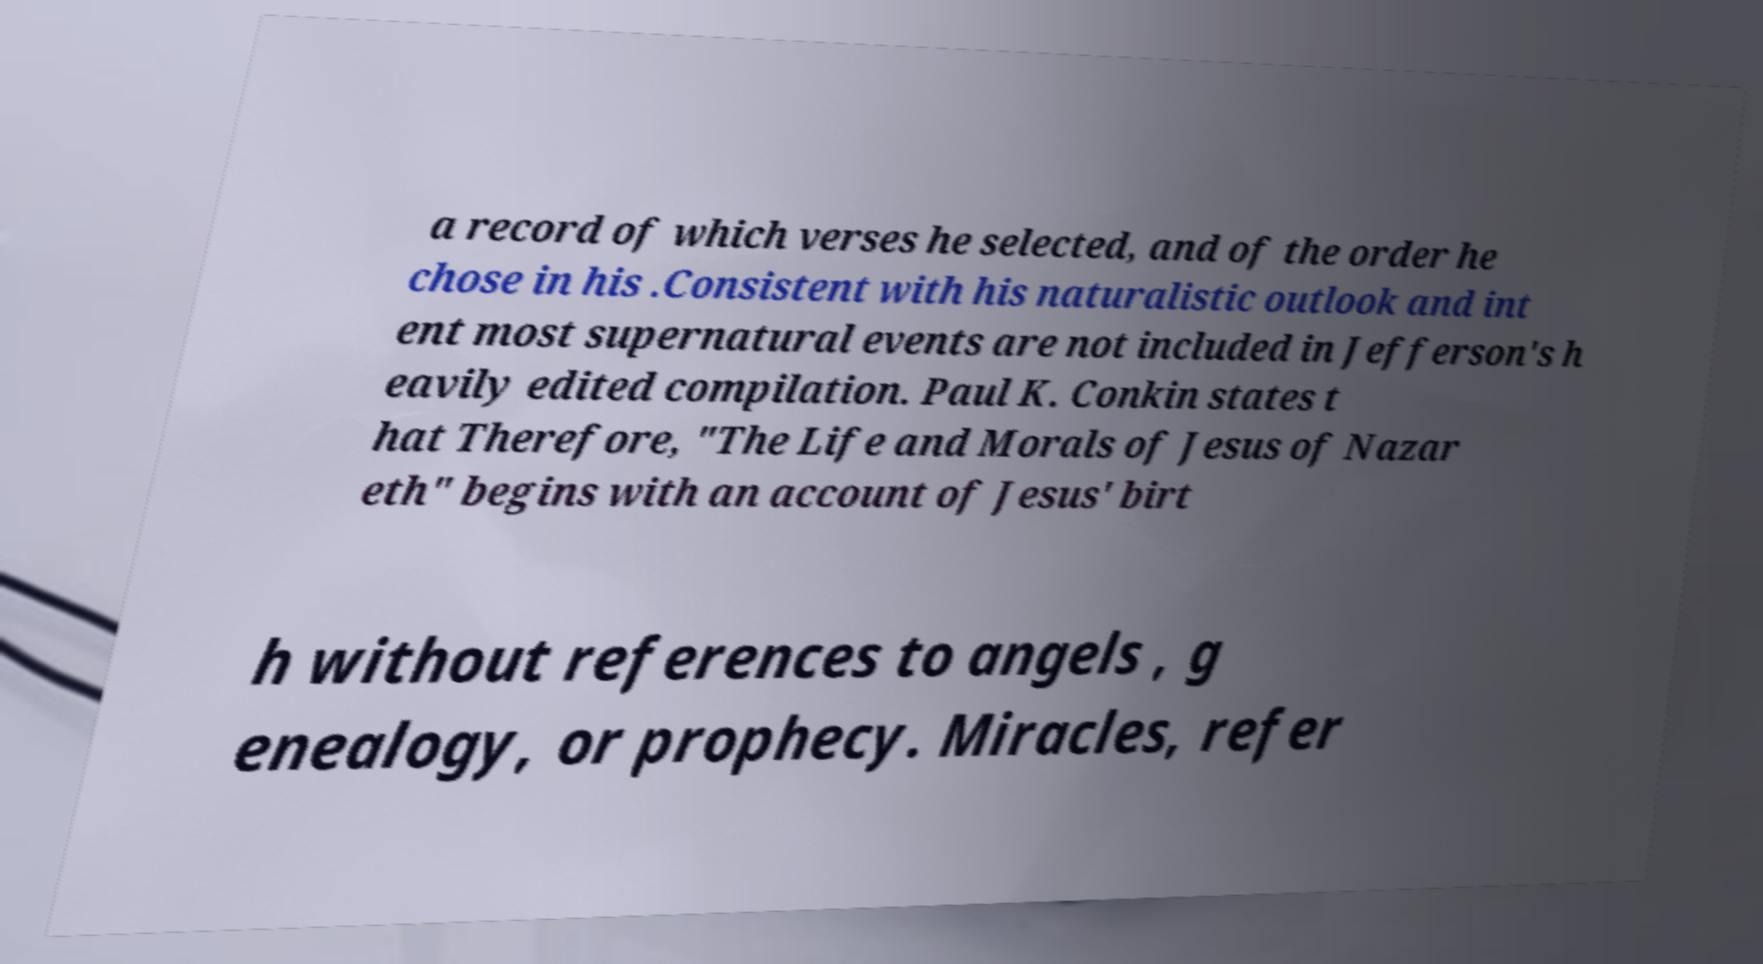Please identify and transcribe the text found in this image. a record of which verses he selected, and of the order he chose in his .Consistent with his naturalistic outlook and int ent most supernatural events are not included in Jefferson's h eavily edited compilation. Paul K. Conkin states t hat Therefore, "The Life and Morals of Jesus of Nazar eth" begins with an account of Jesus' birt h without references to angels , g enealogy, or prophecy. Miracles, refer 